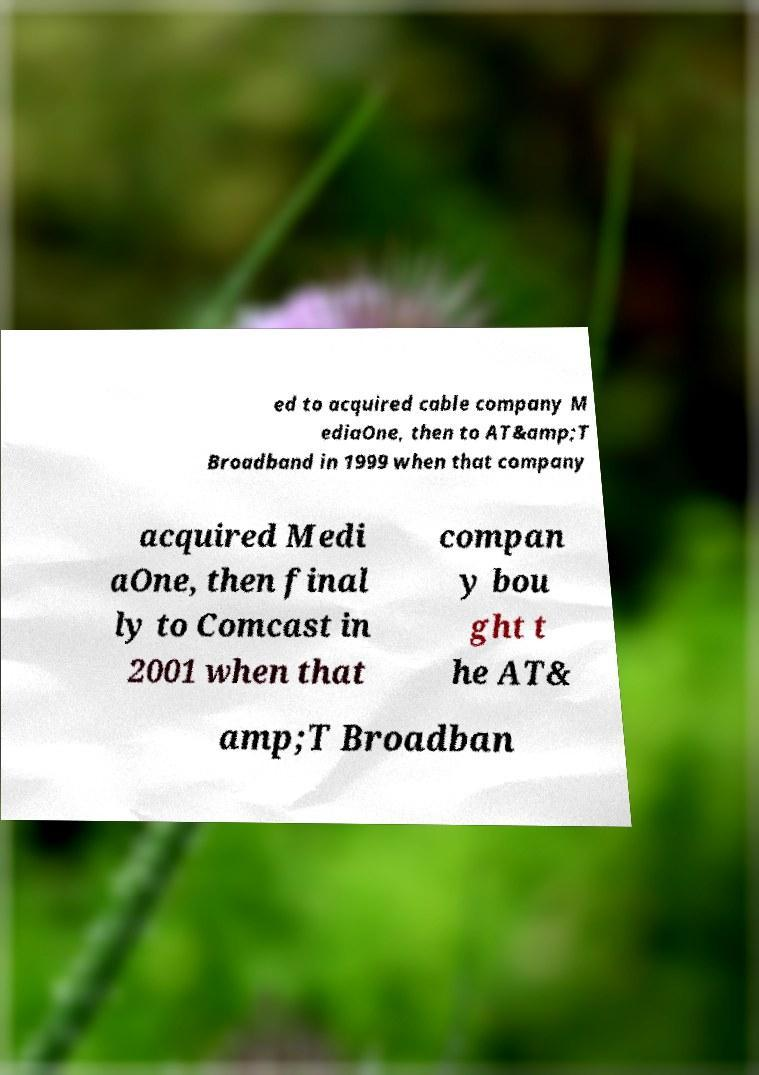Can you accurately transcribe the text from the provided image for me? ed to acquired cable company M ediaOne, then to AT&amp;T Broadband in 1999 when that company acquired Medi aOne, then final ly to Comcast in 2001 when that compan y bou ght t he AT& amp;T Broadban 